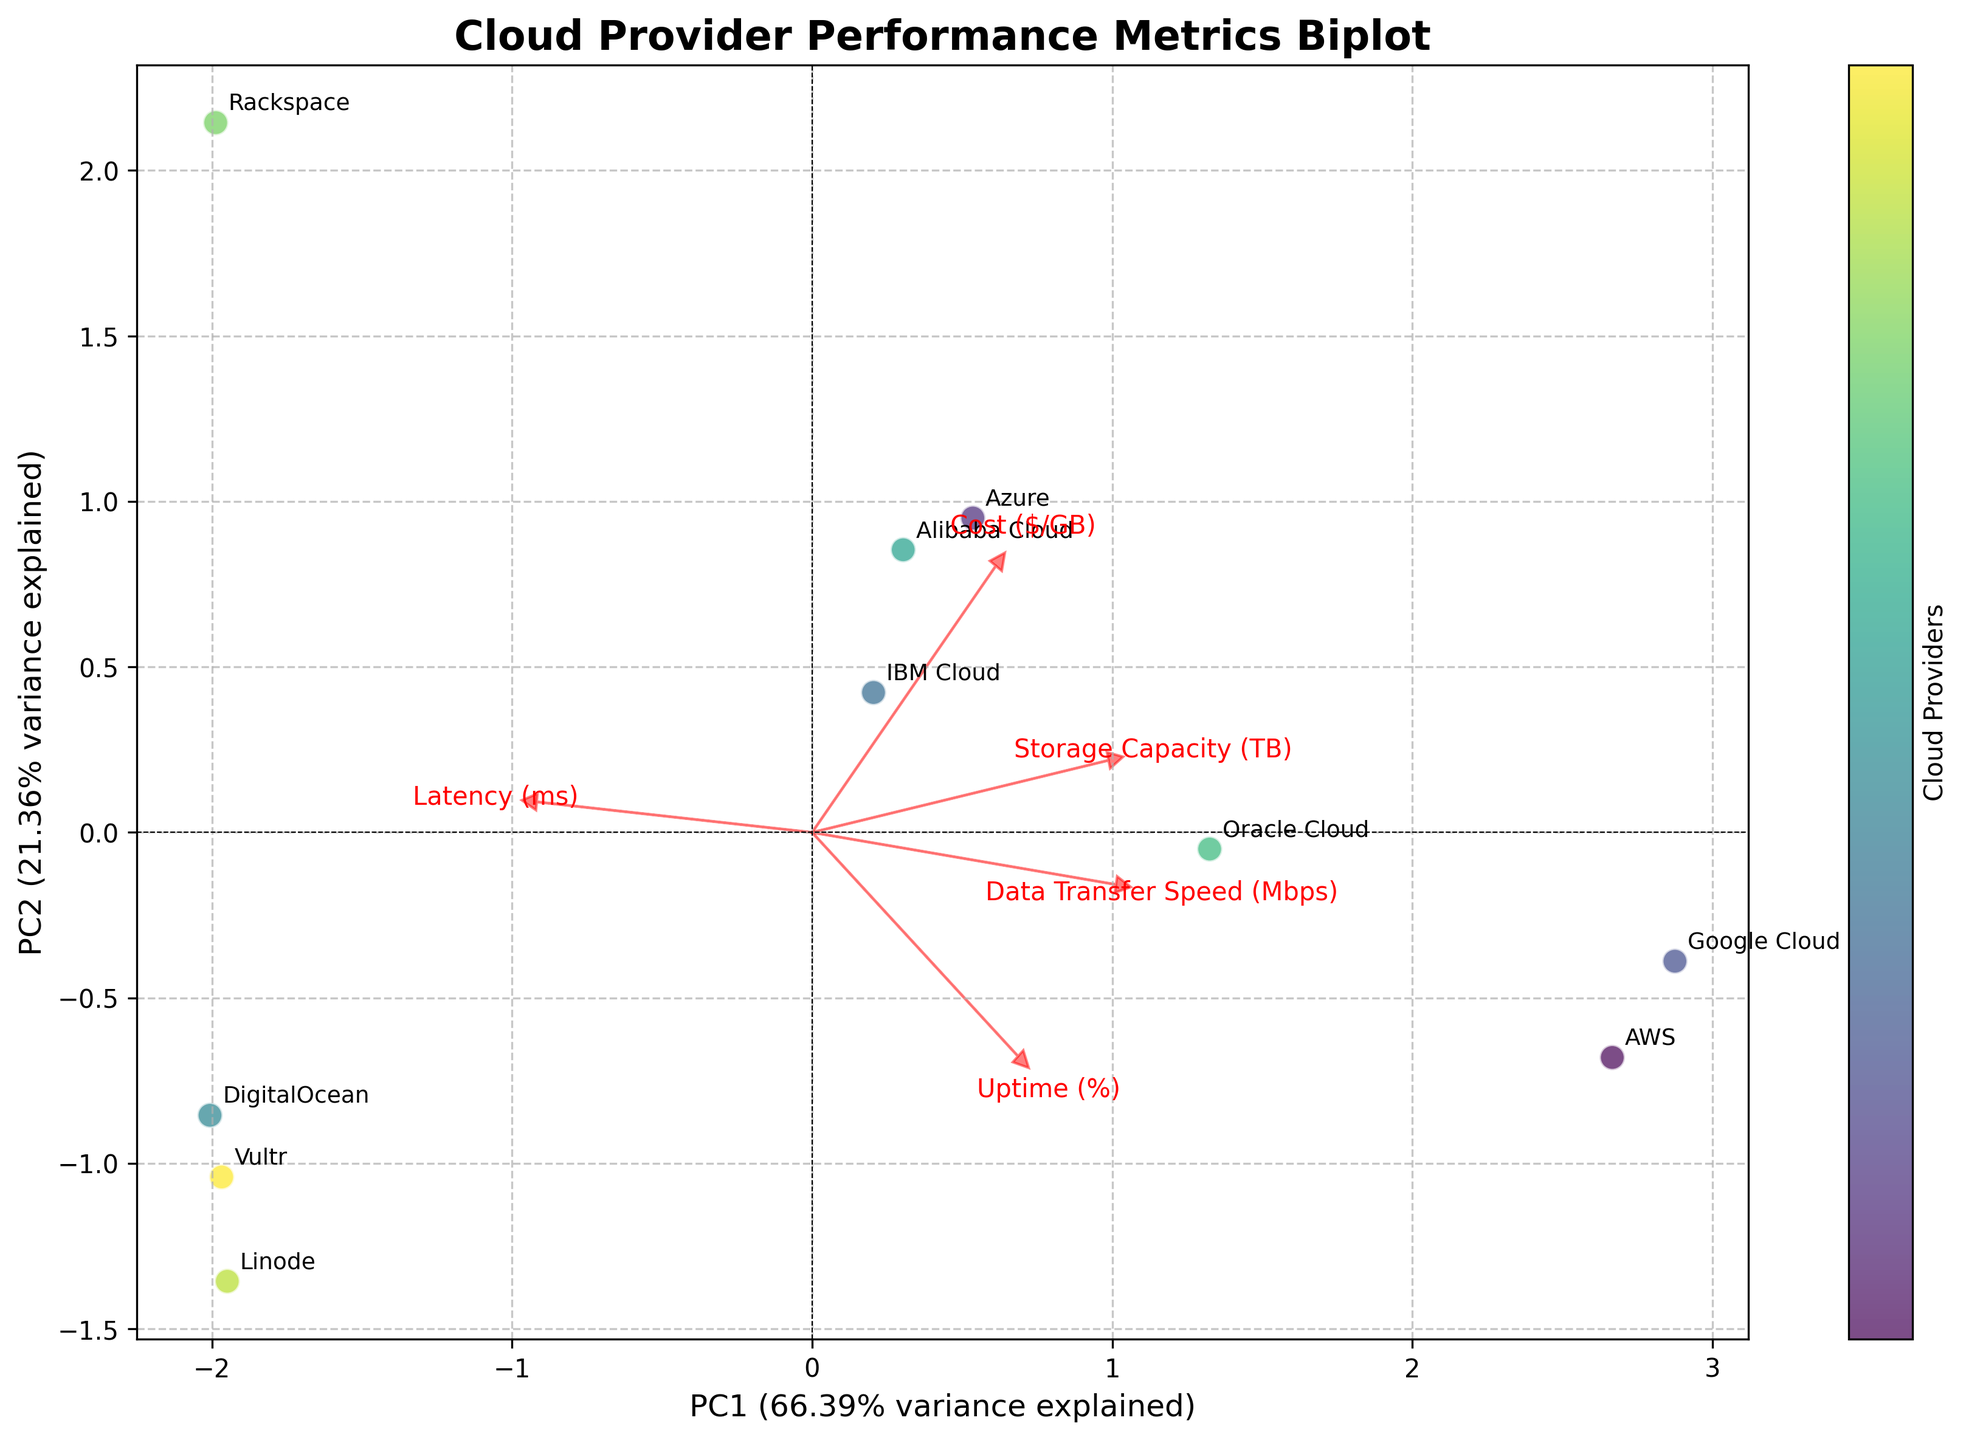What's the title of the plot? The title of the plot is printed at the top and usually summarizes the content.
Answer: Cloud Provider Performance Metrics Biplot How many cloud providers are depicted in the plot? Each point in the scatter plot represents a cloud provider. Count all the labeled points to get the total number.
Answer: 10 Which cloud provider has the lowest latency? Identify the provider that is located furthest to the left along the PC1 axis, as the figure suggests that PCA components correlate with original metrics.
Answer: AWS What feature arrows point towards the upper right quadrant? Feature loadings are represented by arrows. Observe which arrows point towards the upper right quadrant of the plot.
Answer: Data Transfer Speed (Mbps) and Storage Capacity (TB) Which two cloud providers are closest to each other on the plot? Locate the two providers that have the smallest Euclidean distance between their coordinates in the PCA-transformed space.
Answer: DigitalOcean and Vultr Which feature has the highest contribution to PC2? Look at the length and direction of the arrows along the PC2 axis, which represents the variance explained by the second principal component.
Answer: Uptime (%) Is there a feature that correlates negatively with PC1? Identify any arrows that point in the opposite direction along the PC1 axis, indicating a negative contribution to the principal component.
Answer: Latency (ms) Compare the positions of AWS and Rackspace. Which provider has better performance based on Data Transfer Speed? Check the relative positions of AWS and Rackspace along the direction of the Data Transfer Speed (Mbps) arrow. The further in that direction, the higher the performance.
Answer: AWS How much variance is explained by PC1 and PC2 together? Sum the individual explained variances of PC1 and PC2 as provided on the axes labels of the plot.
Answer: Approximately 67% Which cloud providers have a similar cost performance? Look for providers that cluster closely relative to the direction of the Cost ($/GB) arrow, indicating similar performance metrics in terms of cost.
Answer: Azure and Oracle Cloud 